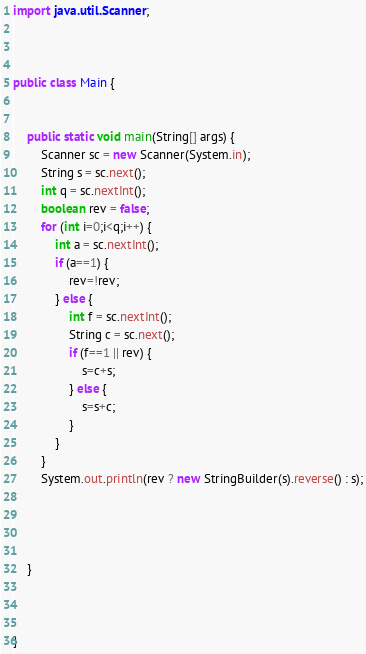Convert code to text. <code><loc_0><loc_0><loc_500><loc_500><_Java_>


import java.util.Scanner;



public class Main {


	public static void main(String[] args) {
		Scanner sc = new Scanner(System.in);
		String s = sc.next();
		int q = sc.nextInt();
		boolean rev = false;
		for (int i=0;i<q;i++) {
			int a = sc.nextInt();
			if (a==1) {
				rev=!rev;
			} else {
				int f = sc.nextInt();
				String c = sc.next();
				if (f==1 || rev) {
					s=c+s;
				} else {
					s=s+c;
				}
			}
		}
		System.out.println(rev ? new StringBuilder(s).reverse() : s);



	
	}
	


}



</code> 